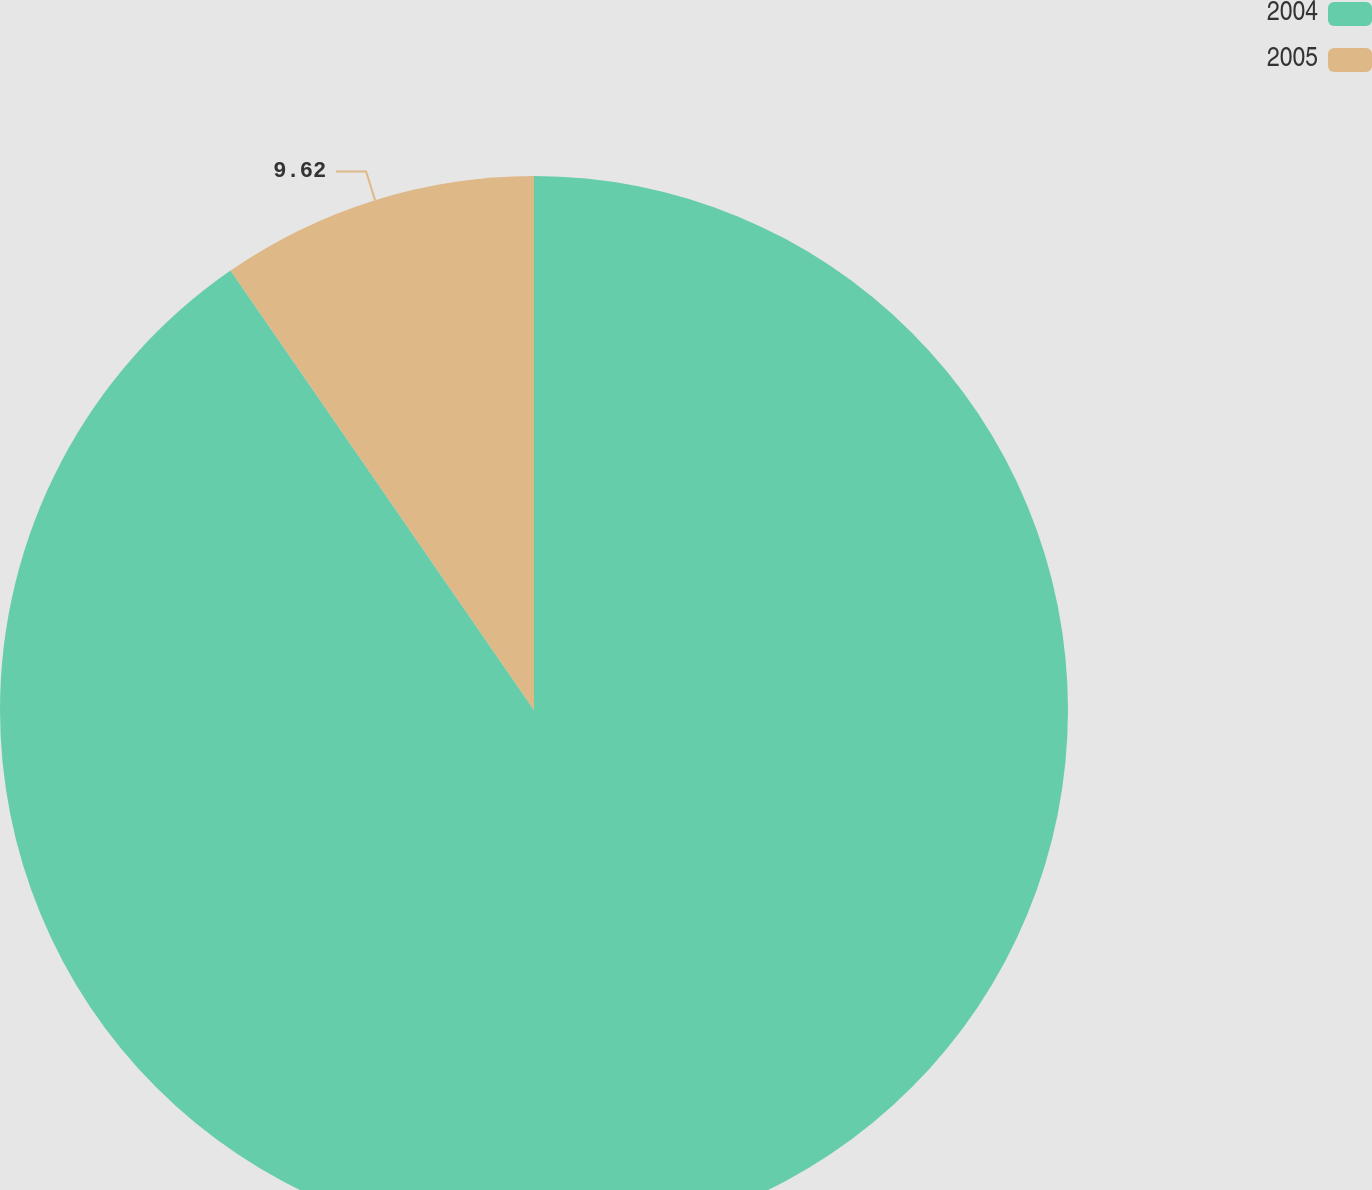<chart> <loc_0><loc_0><loc_500><loc_500><pie_chart><fcel>2004<fcel>2005<nl><fcel>90.38%<fcel>9.62%<nl></chart> 